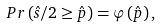<formula> <loc_0><loc_0><loc_500><loc_500>P r \left ( \hat { s } / 2 \geq \hat { p } \right ) = { \varphi } \left ( \hat { p } \right ) ,</formula> 